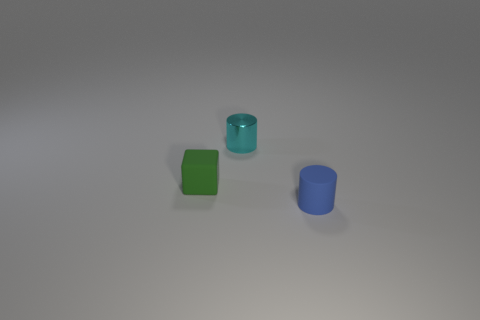Add 3 tiny purple shiny cylinders. How many objects exist? 6 Subtract all cylinders. How many objects are left? 1 Add 3 cyan objects. How many cyan objects are left? 4 Add 2 tiny rubber cylinders. How many tiny rubber cylinders exist? 3 Subtract 0 red balls. How many objects are left? 3 Subtract all tiny shiny objects. Subtract all green things. How many objects are left? 1 